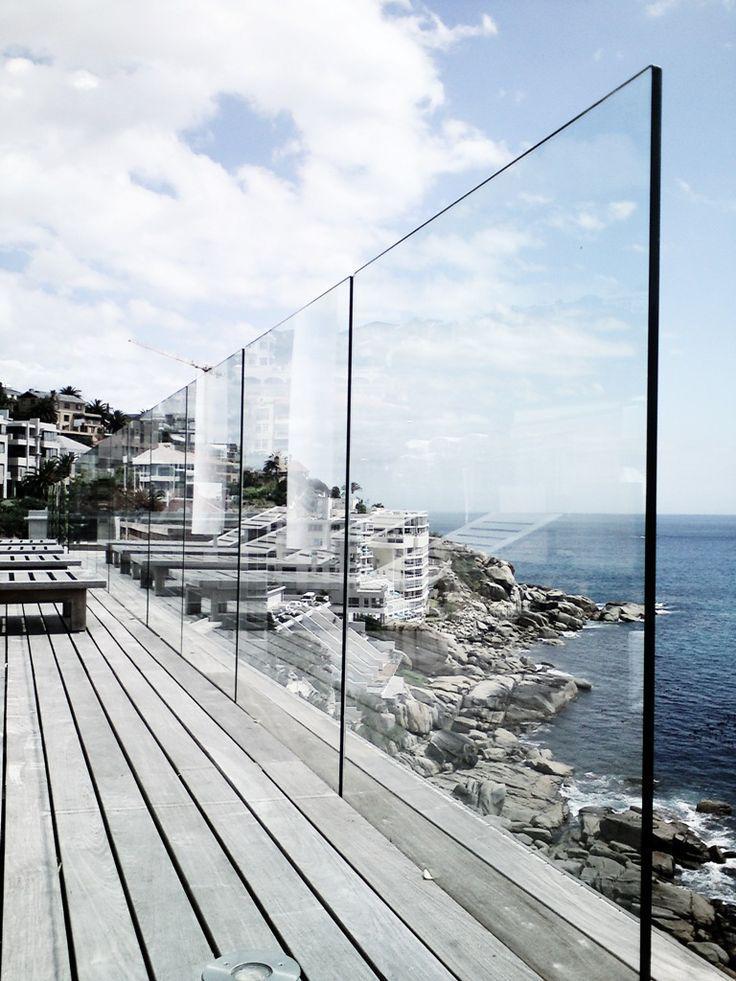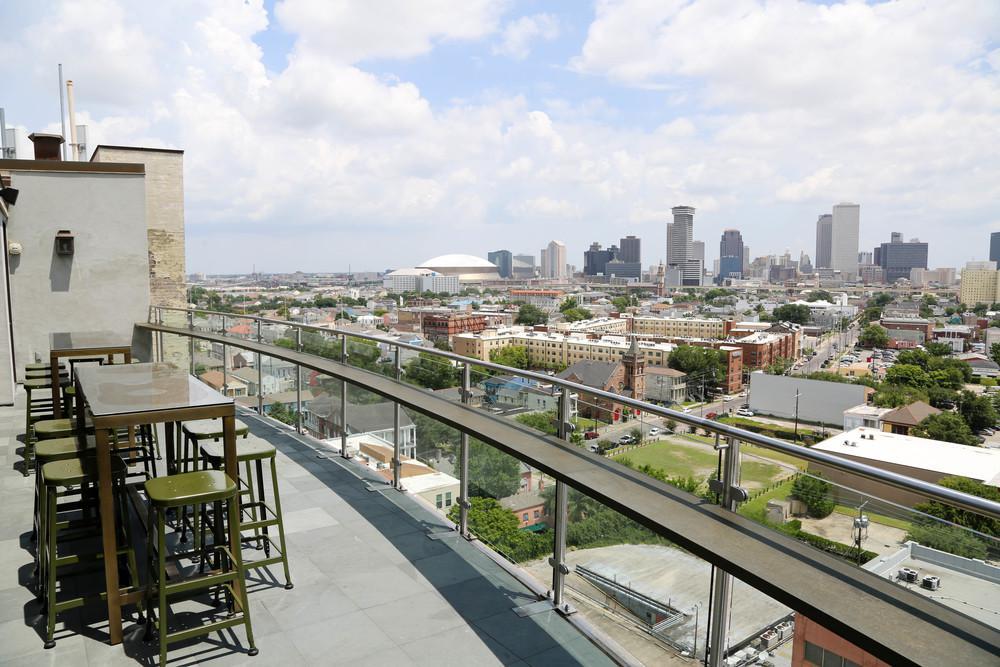The first image is the image on the left, the second image is the image on the right. Considering the images on both sides, is "In one image, a glass-paneled balcony with a 'plank' floor overlooks the ocean on the right." valid? Answer yes or no. Yes. The first image is the image on the left, the second image is the image on the right. Considering the images on both sides, is "there is a wooden deck with glass surrounding it, overlooking the water" valid? Answer yes or no. Yes. 